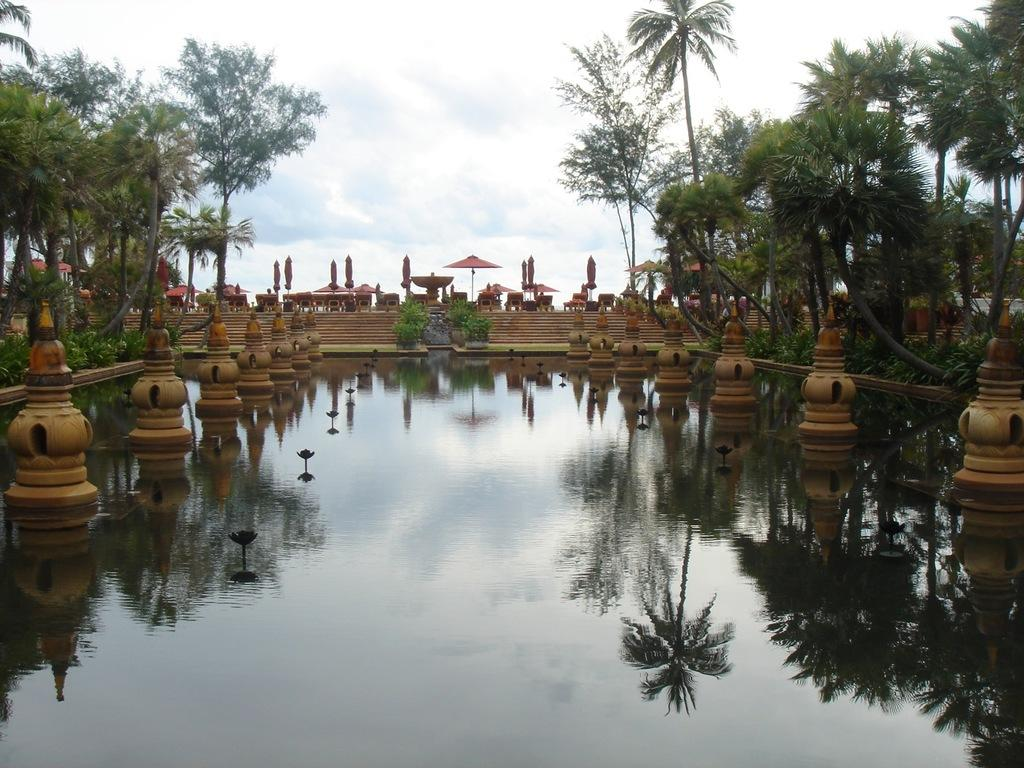What is in the water in the image? There are brown color pillars in the water. What can be seen on the left side of the image? There are trees on the left side of the image. What can be seen on the right side of the image? There are trees on the right side of the image. What is the color of the trees? The trees are green in color. What is visible in the background of the image? The sky is visible in the background of the image. What are the colors of the sky? The sky is blue and white in color. Can you hear the whistle of the cars in the amusement park in the image? There is no mention of cars or an amusement park in the image. The image features brown color pillars in the water, trees on both sides, and a blue and white sky in the background. 